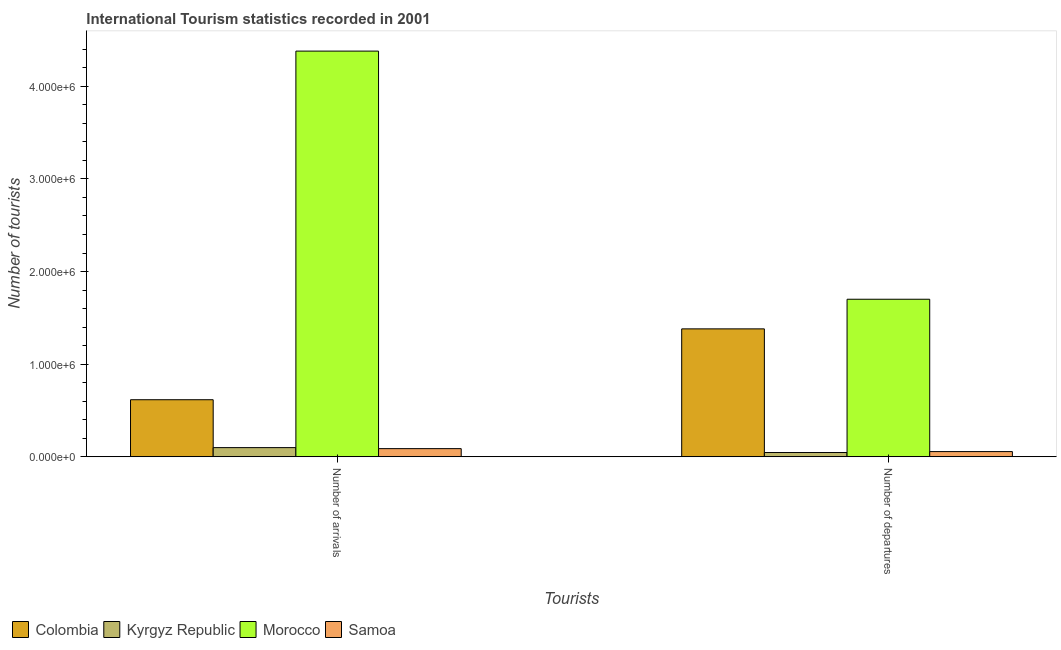Are the number of bars on each tick of the X-axis equal?
Make the answer very short. Yes. How many bars are there on the 1st tick from the left?
Your response must be concise. 4. How many bars are there on the 1st tick from the right?
Your answer should be compact. 4. What is the label of the 1st group of bars from the left?
Provide a succinct answer. Number of arrivals. What is the number of tourist departures in Colombia?
Provide a short and direct response. 1.38e+06. Across all countries, what is the maximum number of tourist departures?
Provide a short and direct response. 1.70e+06. Across all countries, what is the minimum number of tourist departures?
Make the answer very short. 4.60e+04. In which country was the number of tourist arrivals maximum?
Provide a short and direct response. Morocco. In which country was the number of tourist arrivals minimum?
Make the answer very short. Samoa. What is the total number of tourist arrivals in the graph?
Offer a terse response. 5.18e+06. What is the difference between the number of tourist arrivals in Samoa and that in Colombia?
Make the answer very short. -5.28e+05. What is the difference between the number of tourist departures in Colombia and the number of tourist arrivals in Samoa?
Provide a short and direct response. 1.29e+06. What is the average number of tourist arrivals per country?
Offer a very short reply. 1.30e+06. What is the difference between the number of tourist departures and number of tourist arrivals in Kyrgyz Republic?
Give a very brief answer. -5.30e+04. In how many countries, is the number of tourist departures greater than 1600000 ?
Your answer should be compact. 1. What is the ratio of the number of tourist departures in Morocco to that in Colombia?
Make the answer very short. 1.23. What does the 4th bar from the left in Number of departures represents?
Your response must be concise. Samoa. What does the 4th bar from the right in Number of departures represents?
Keep it short and to the point. Colombia. How many bars are there?
Your answer should be compact. 8. Are all the bars in the graph horizontal?
Your response must be concise. No. How many countries are there in the graph?
Ensure brevity in your answer.  4. What is the difference between two consecutive major ticks on the Y-axis?
Offer a very short reply. 1.00e+06. Are the values on the major ticks of Y-axis written in scientific E-notation?
Your answer should be very brief. Yes. Does the graph contain grids?
Your answer should be very brief. No. Where does the legend appear in the graph?
Your answer should be compact. Bottom left. What is the title of the graph?
Give a very brief answer. International Tourism statistics recorded in 2001. Does "Latin America(all income levels)" appear as one of the legend labels in the graph?
Give a very brief answer. No. What is the label or title of the X-axis?
Ensure brevity in your answer.  Tourists. What is the label or title of the Y-axis?
Your response must be concise. Number of tourists. What is the Number of tourists of Colombia in Number of arrivals?
Provide a short and direct response. 6.16e+05. What is the Number of tourists in Kyrgyz Republic in Number of arrivals?
Keep it short and to the point. 9.90e+04. What is the Number of tourists of Morocco in Number of arrivals?
Provide a succinct answer. 4.38e+06. What is the Number of tourists of Samoa in Number of arrivals?
Provide a short and direct response. 8.80e+04. What is the Number of tourists in Colombia in Number of departures?
Give a very brief answer. 1.38e+06. What is the Number of tourists in Kyrgyz Republic in Number of departures?
Your response must be concise. 4.60e+04. What is the Number of tourists in Morocco in Number of departures?
Provide a short and direct response. 1.70e+06. What is the Number of tourists in Samoa in Number of departures?
Offer a very short reply. 5.60e+04. Across all Tourists, what is the maximum Number of tourists of Colombia?
Your response must be concise. 1.38e+06. Across all Tourists, what is the maximum Number of tourists of Kyrgyz Republic?
Ensure brevity in your answer.  9.90e+04. Across all Tourists, what is the maximum Number of tourists of Morocco?
Your answer should be compact. 4.38e+06. Across all Tourists, what is the maximum Number of tourists in Samoa?
Ensure brevity in your answer.  8.80e+04. Across all Tourists, what is the minimum Number of tourists in Colombia?
Provide a short and direct response. 6.16e+05. Across all Tourists, what is the minimum Number of tourists in Kyrgyz Republic?
Offer a very short reply. 4.60e+04. Across all Tourists, what is the minimum Number of tourists of Morocco?
Offer a terse response. 1.70e+06. Across all Tourists, what is the minimum Number of tourists in Samoa?
Your answer should be very brief. 5.60e+04. What is the total Number of tourists of Colombia in the graph?
Offer a terse response. 2.00e+06. What is the total Number of tourists of Kyrgyz Republic in the graph?
Provide a short and direct response. 1.45e+05. What is the total Number of tourists in Morocco in the graph?
Keep it short and to the point. 6.08e+06. What is the total Number of tourists in Samoa in the graph?
Your answer should be very brief. 1.44e+05. What is the difference between the Number of tourists in Colombia in Number of arrivals and that in Number of departures?
Offer a very short reply. -7.65e+05. What is the difference between the Number of tourists in Kyrgyz Republic in Number of arrivals and that in Number of departures?
Offer a very short reply. 5.30e+04. What is the difference between the Number of tourists in Morocco in Number of arrivals and that in Number of departures?
Your answer should be very brief. 2.68e+06. What is the difference between the Number of tourists in Samoa in Number of arrivals and that in Number of departures?
Offer a very short reply. 3.20e+04. What is the difference between the Number of tourists of Colombia in Number of arrivals and the Number of tourists of Kyrgyz Republic in Number of departures?
Provide a short and direct response. 5.70e+05. What is the difference between the Number of tourists in Colombia in Number of arrivals and the Number of tourists in Morocco in Number of departures?
Keep it short and to the point. -1.08e+06. What is the difference between the Number of tourists in Colombia in Number of arrivals and the Number of tourists in Samoa in Number of departures?
Provide a succinct answer. 5.60e+05. What is the difference between the Number of tourists in Kyrgyz Republic in Number of arrivals and the Number of tourists in Morocco in Number of departures?
Keep it short and to the point. -1.60e+06. What is the difference between the Number of tourists in Kyrgyz Republic in Number of arrivals and the Number of tourists in Samoa in Number of departures?
Your answer should be very brief. 4.30e+04. What is the difference between the Number of tourists of Morocco in Number of arrivals and the Number of tourists of Samoa in Number of departures?
Offer a terse response. 4.32e+06. What is the average Number of tourists of Colombia per Tourists?
Keep it short and to the point. 9.98e+05. What is the average Number of tourists in Kyrgyz Republic per Tourists?
Your answer should be very brief. 7.25e+04. What is the average Number of tourists in Morocco per Tourists?
Offer a very short reply. 3.04e+06. What is the average Number of tourists of Samoa per Tourists?
Your response must be concise. 7.20e+04. What is the difference between the Number of tourists of Colombia and Number of tourists of Kyrgyz Republic in Number of arrivals?
Provide a succinct answer. 5.17e+05. What is the difference between the Number of tourists in Colombia and Number of tourists in Morocco in Number of arrivals?
Give a very brief answer. -3.76e+06. What is the difference between the Number of tourists of Colombia and Number of tourists of Samoa in Number of arrivals?
Give a very brief answer. 5.28e+05. What is the difference between the Number of tourists of Kyrgyz Republic and Number of tourists of Morocco in Number of arrivals?
Offer a very short reply. -4.28e+06. What is the difference between the Number of tourists in Kyrgyz Republic and Number of tourists in Samoa in Number of arrivals?
Your response must be concise. 1.10e+04. What is the difference between the Number of tourists in Morocco and Number of tourists in Samoa in Number of arrivals?
Provide a succinct answer. 4.29e+06. What is the difference between the Number of tourists in Colombia and Number of tourists in Kyrgyz Republic in Number of departures?
Your answer should be very brief. 1.34e+06. What is the difference between the Number of tourists of Colombia and Number of tourists of Morocco in Number of departures?
Offer a very short reply. -3.20e+05. What is the difference between the Number of tourists in Colombia and Number of tourists in Samoa in Number of departures?
Your answer should be compact. 1.32e+06. What is the difference between the Number of tourists of Kyrgyz Republic and Number of tourists of Morocco in Number of departures?
Provide a succinct answer. -1.66e+06. What is the difference between the Number of tourists in Kyrgyz Republic and Number of tourists in Samoa in Number of departures?
Your answer should be compact. -10000. What is the difference between the Number of tourists in Morocco and Number of tourists in Samoa in Number of departures?
Ensure brevity in your answer.  1.64e+06. What is the ratio of the Number of tourists of Colombia in Number of arrivals to that in Number of departures?
Your answer should be compact. 0.45. What is the ratio of the Number of tourists of Kyrgyz Republic in Number of arrivals to that in Number of departures?
Provide a succinct answer. 2.15. What is the ratio of the Number of tourists of Morocco in Number of arrivals to that in Number of departures?
Offer a very short reply. 2.58. What is the ratio of the Number of tourists in Samoa in Number of arrivals to that in Number of departures?
Ensure brevity in your answer.  1.57. What is the difference between the highest and the second highest Number of tourists of Colombia?
Keep it short and to the point. 7.65e+05. What is the difference between the highest and the second highest Number of tourists in Kyrgyz Republic?
Keep it short and to the point. 5.30e+04. What is the difference between the highest and the second highest Number of tourists of Morocco?
Provide a succinct answer. 2.68e+06. What is the difference between the highest and the second highest Number of tourists of Samoa?
Your answer should be very brief. 3.20e+04. What is the difference between the highest and the lowest Number of tourists of Colombia?
Your answer should be compact. 7.65e+05. What is the difference between the highest and the lowest Number of tourists of Kyrgyz Republic?
Provide a short and direct response. 5.30e+04. What is the difference between the highest and the lowest Number of tourists of Morocco?
Your answer should be compact. 2.68e+06. What is the difference between the highest and the lowest Number of tourists in Samoa?
Make the answer very short. 3.20e+04. 